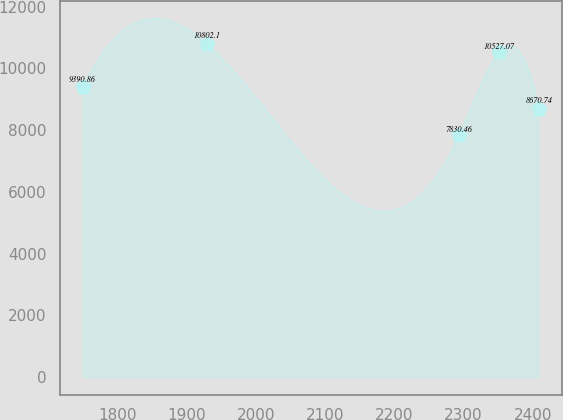<chart> <loc_0><loc_0><loc_500><loc_500><line_chart><ecel><fcel>Unnamed: 1<nl><fcel>1749.54<fcel>9390.86<nl><fcel>1928.72<fcel>10802.1<nl><fcel>2293.63<fcel>7830.46<nl><fcel>2351.18<fcel>10527.1<nl><fcel>2408.73<fcel>8670.74<nl></chart> 